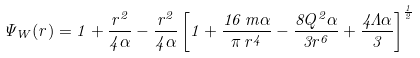Convert formula to latex. <formula><loc_0><loc_0><loc_500><loc_500>\Psi _ { W } ( r ) = 1 + \frac { r ^ { 2 } } { 4 \alpha } - \frac { r ^ { 2 } } { 4 \alpha } \left [ 1 + \frac { 1 6 \, m \alpha } { \pi \, r ^ { 4 } } - \frac { 8 Q ^ { 2 } \alpha } { 3 r ^ { 6 } } + \frac { 4 \Lambda \alpha } { 3 } \right ] ^ { \frac { 1 } { 2 } }</formula> 